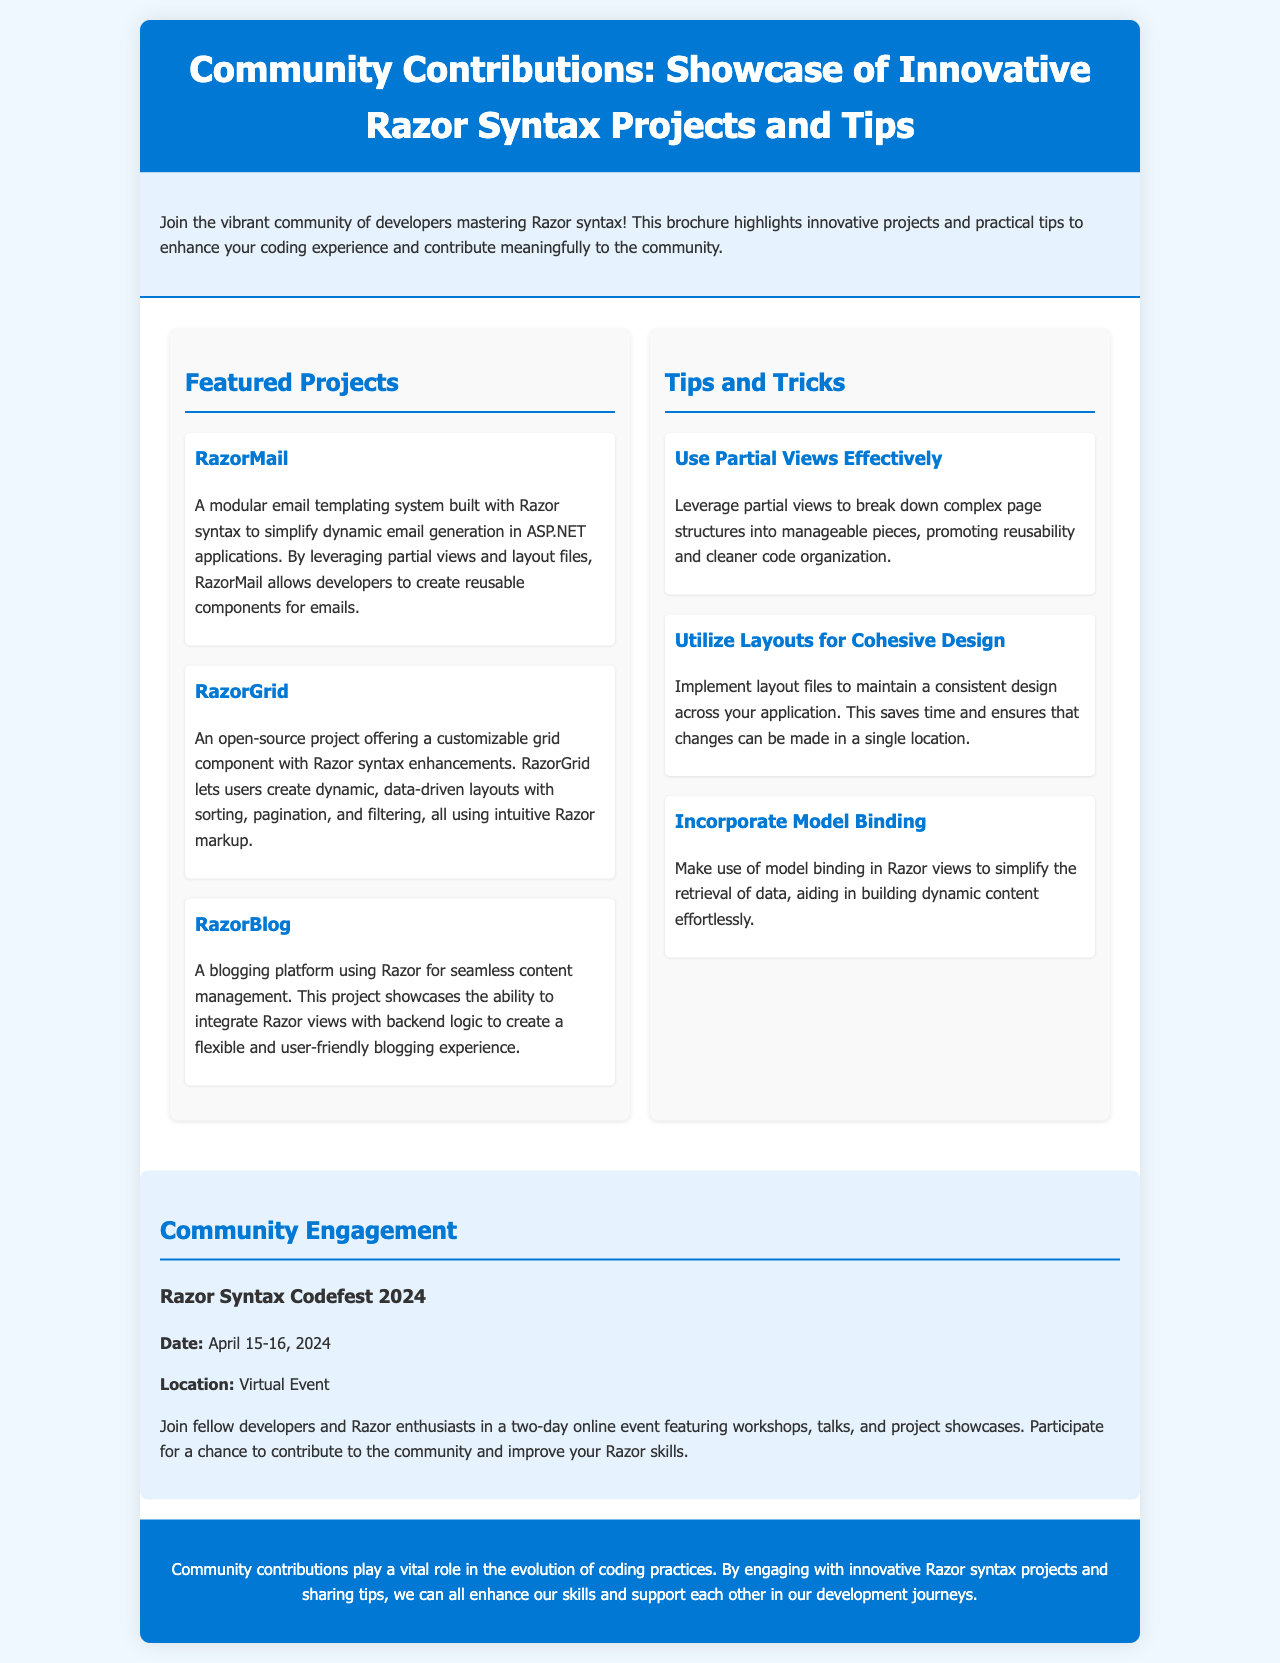What is the title of the brochure? The title of the brochure is stated in the header section.
Answer: Community Contributions: Showcase of Innovative Razor Syntax Projects and Tips How many featured projects are listed? The number of featured projects can be counted in the section that contains the project descriptions.
Answer: Three What is the name of the blogging platform project? The name of the project related to blogging is mentioned in the featured projects section.
Answer: RazorBlog What is one of the tips provided for effective Razor coding? The tips were described in the section dedicated to tips and tricks for Razor syntax.
Answer: Use Partial Views Effectively When is the Razor Syntax Codefest 2024 scheduled? The event date is explicitly mentioned in the community engagement section.
Answer: April 15-16, 2024 What color is used for the header background? The header background color is noted in the style section of the code.
Answer: #0078d4 What type of event is the Razor Syntax Codefest 2024? The nature of the event is outlined in the community engagement section.
Answer: Virtual Event What does RazorMail simplify? The simplification element is specified in the description of the RazorMail project.
Answer: Dynamic email generation 